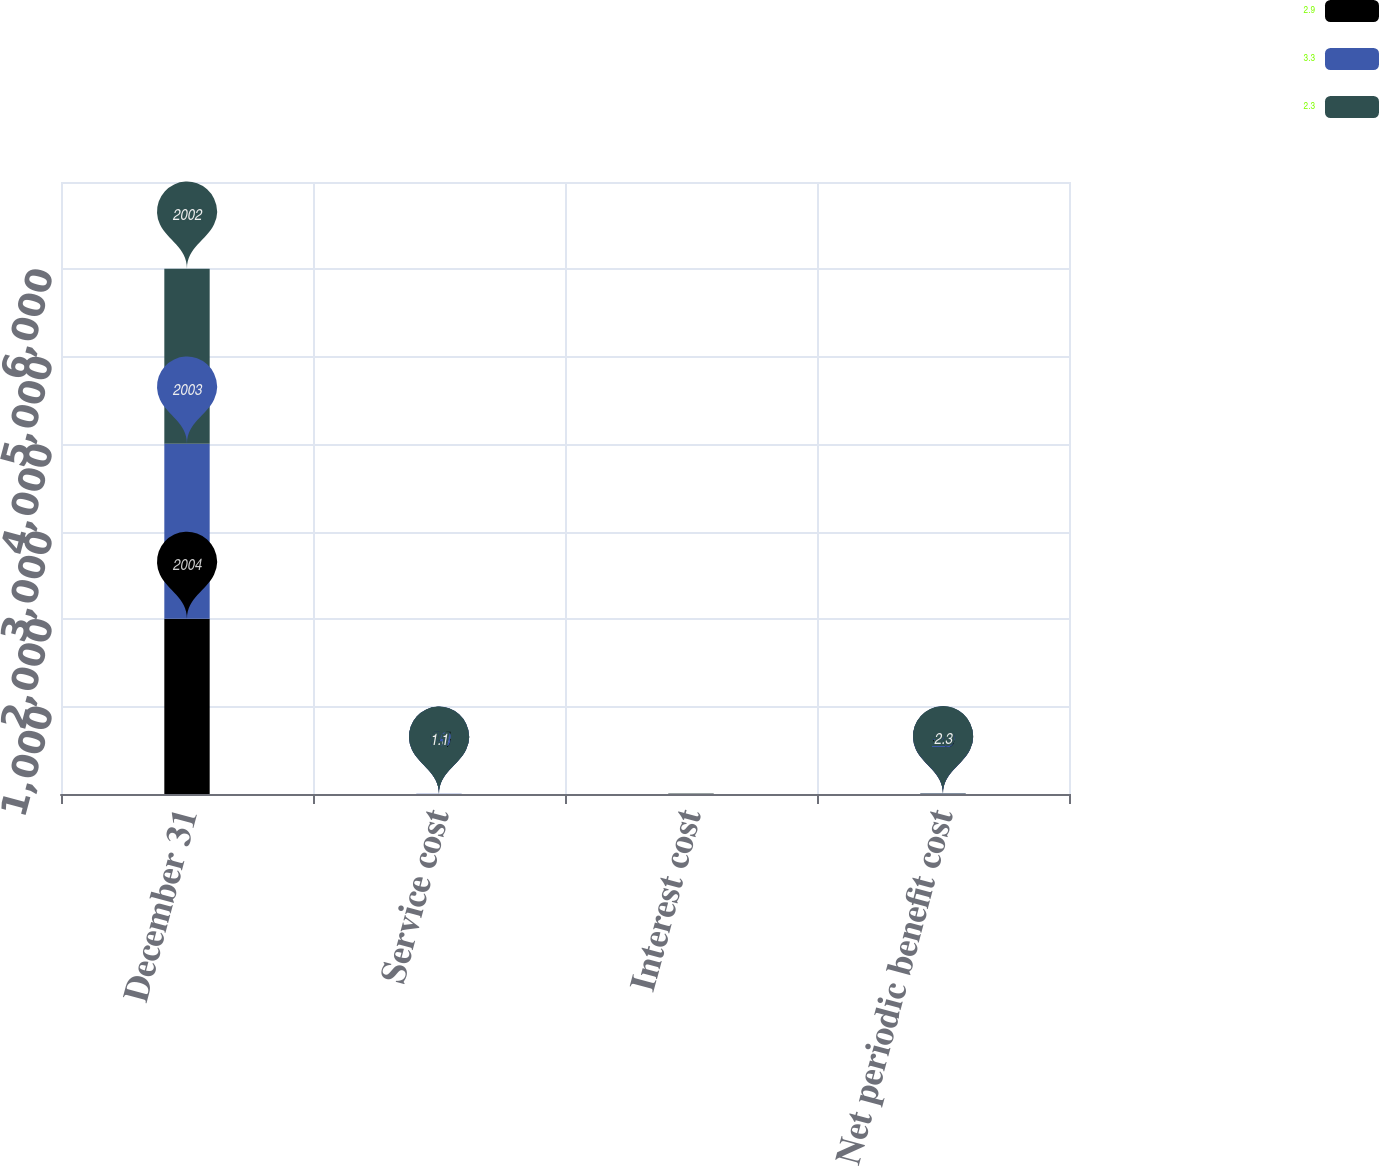Convert chart to OTSL. <chart><loc_0><loc_0><loc_500><loc_500><stacked_bar_chart><ecel><fcel>December 31<fcel>Service cost<fcel>Interest cost<fcel>Net periodic benefit cost<nl><fcel>2.9<fcel>2004<fcel>1.4<fcel>1.7<fcel>3.3<nl><fcel>3.3<fcel>2003<fcel>1.3<fcel>1.5<fcel>2.9<nl><fcel>2.3<fcel>2002<fcel>1.1<fcel>1.2<fcel>2.3<nl></chart> 